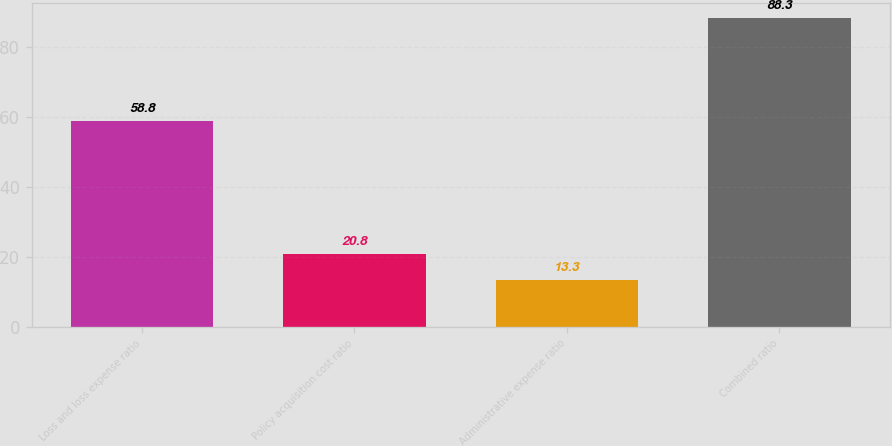<chart> <loc_0><loc_0><loc_500><loc_500><bar_chart><fcel>Loss and loss expense ratio<fcel>Policy acquisition cost ratio<fcel>Administrative expense ratio<fcel>Combined ratio<nl><fcel>58.8<fcel>20.8<fcel>13.3<fcel>88.3<nl></chart> 